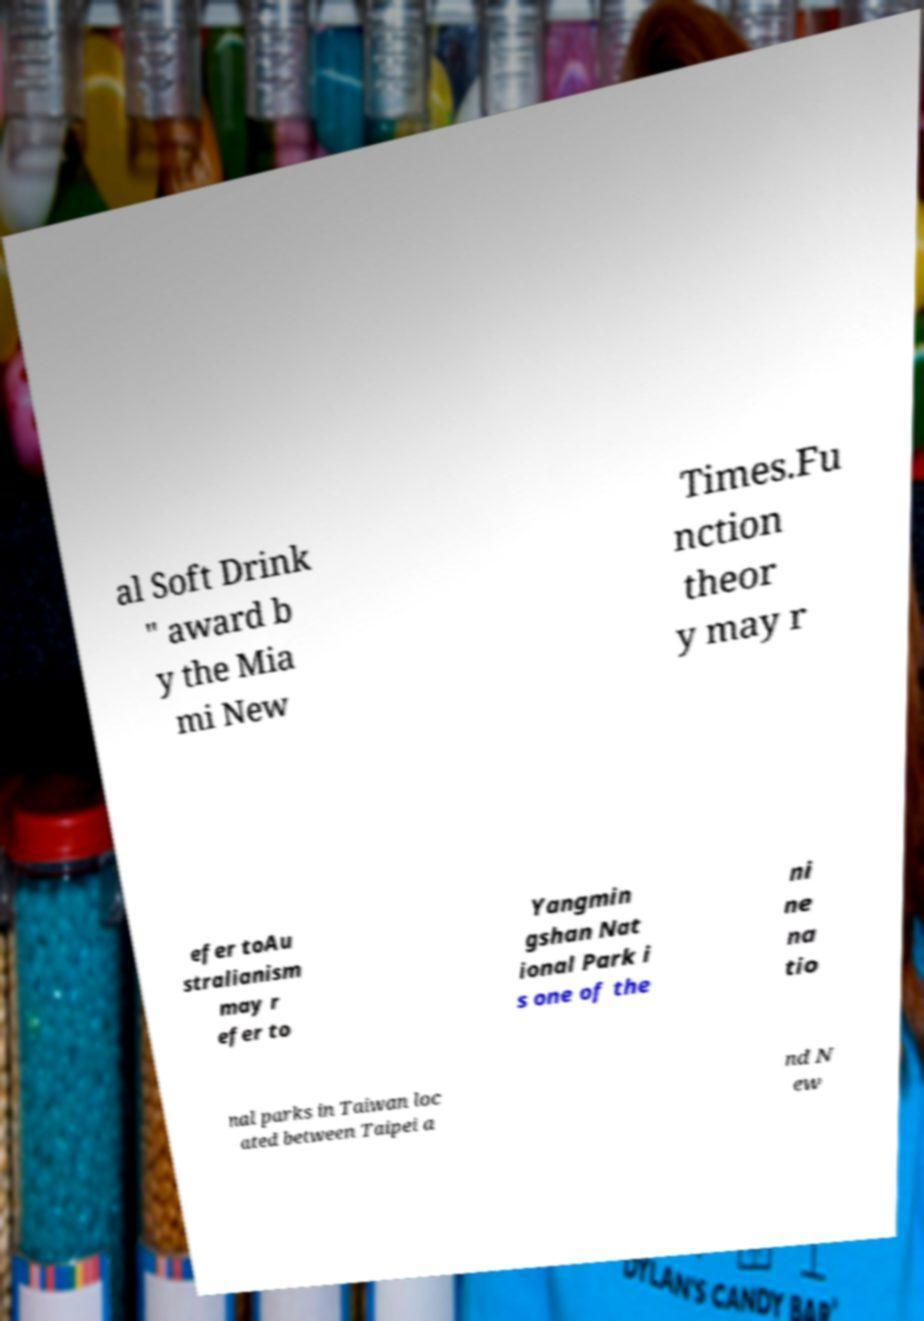Can you read and provide the text displayed in the image?This photo seems to have some interesting text. Can you extract and type it out for me? al Soft Drink " award b y the Mia mi New Times.Fu nction theor y may r efer toAu stralianism may r efer to Yangmin gshan Nat ional Park i s one of the ni ne na tio nal parks in Taiwan loc ated between Taipei a nd N ew 